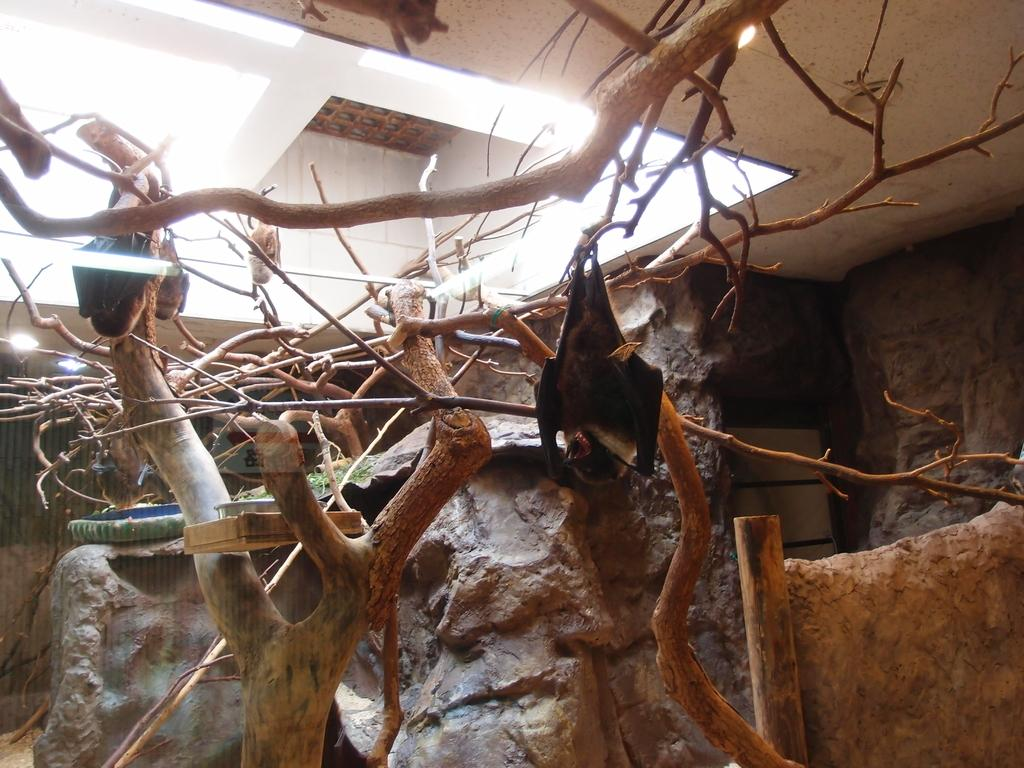What is the main object in the image? There is a tree in the image. What is hanging from the tree's branches? The tree has bats hanging from its branches. What can be seen in the background of the image? There is a rock in the background of the image. What is visible at the top of the image? The top of the image features a roof. How many men are resting on the appliance in the image? There are no men or appliances present in the image. 